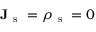<formula> <loc_0><loc_0><loc_500><loc_500>J _ { s } = \rho _ { s } = 0</formula> 